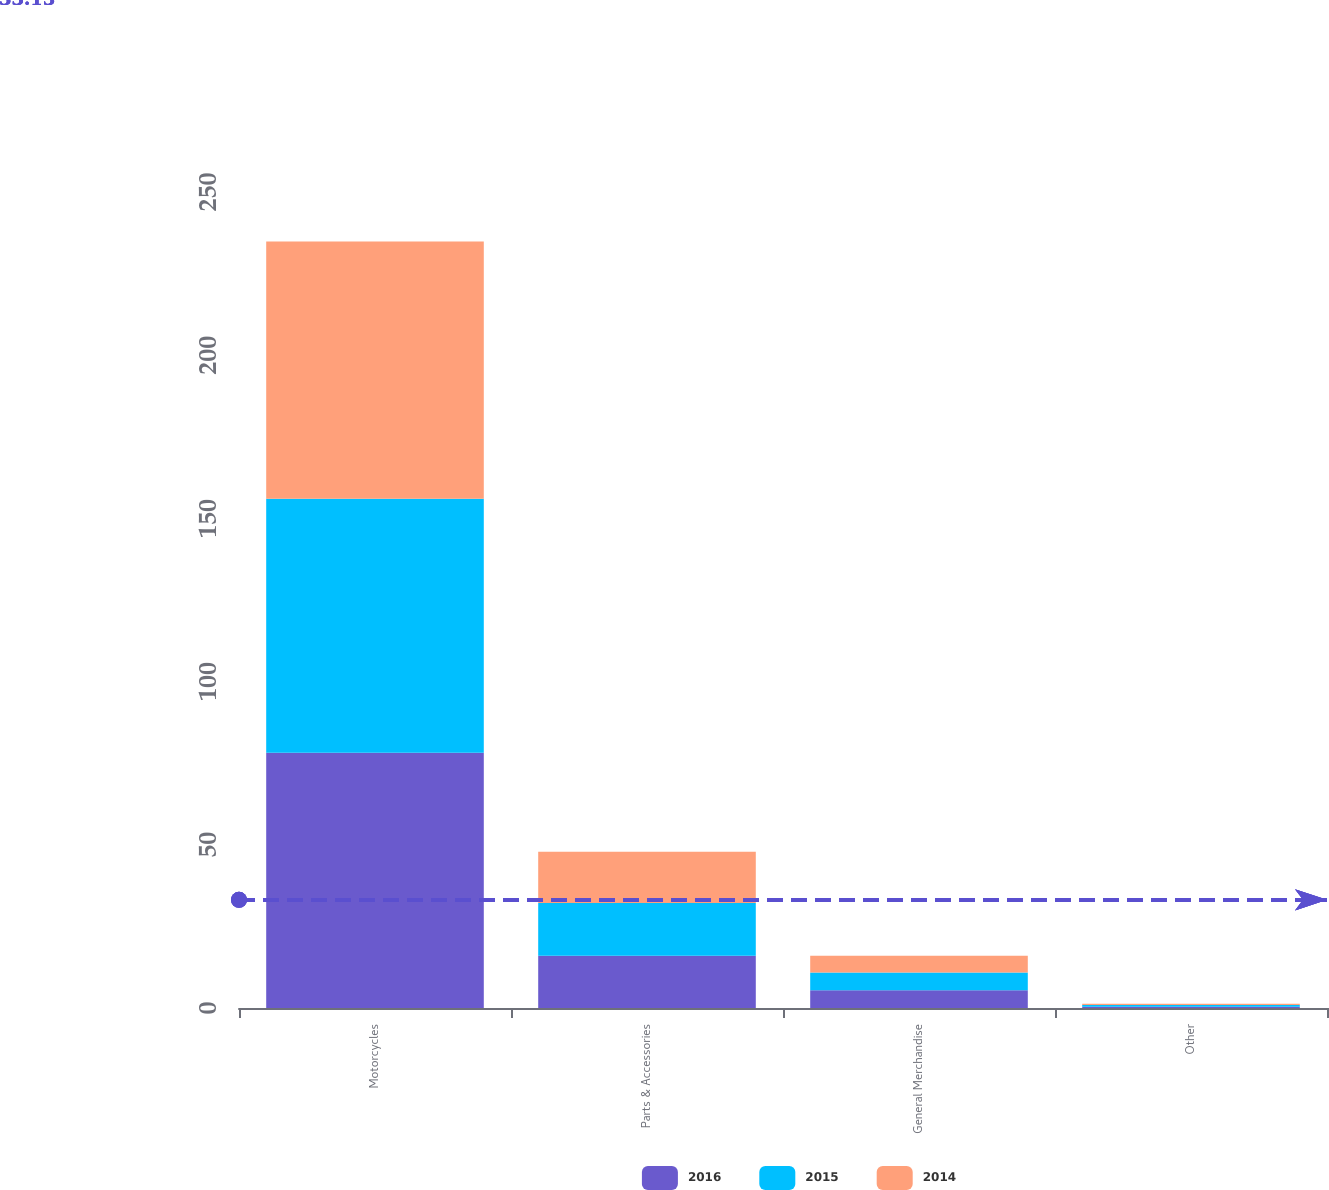Convert chart to OTSL. <chart><loc_0><loc_0><loc_500><loc_500><stacked_bar_chart><ecel><fcel>Motorcycles<fcel>Parts & Accessories<fcel>General Merchandise<fcel>Other<nl><fcel>2016<fcel>78.2<fcel>16<fcel>5.4<fcel>0.4<nl><fcel>2015<fcel>77.8<fcel>16.2<fcel>5.5<fcel>0.5<nl><fcel>2014<fcel>78.8<fcel>15.7<fcel>5.1<fcel>0.4<nl></chart> 